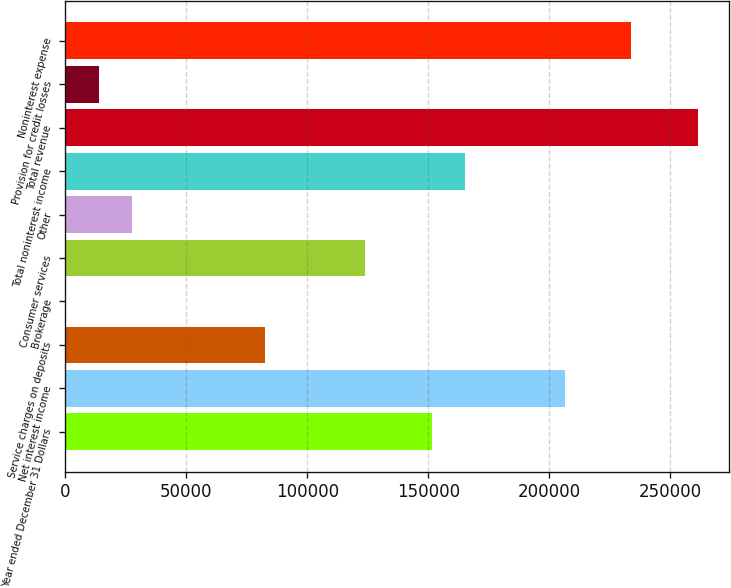Convert chart. <chart><loc_0><loc_0><loc_500><loc_500><bar_chart><fcel>Year ended December 31 Dollars<fcel>Net interest income<fcel>Service charges on deposits<fcel>Brokerage<fcel>Consumer services<fcel>Other<fcel>Total noninterest income<fcel>Total revenue<fcel>Provision for credit losses<fcel>Noninterest expense<nl><fcel>151421<fcel>206396<fcel>82702.2<fcel>240<fcel>123933<fcel>27727.4<fcel>165164<fcel>261370<fcel>13983.7<fcel>233883<nl></chart> 